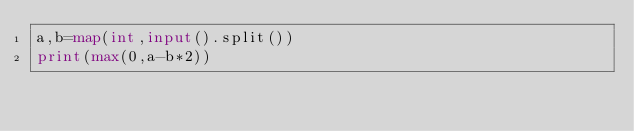<code> <loc_0><loc_0><loc_500><loc_500><_Python_>a,b=map(int,input().split())
print(max(0,a-b*2))</code> 